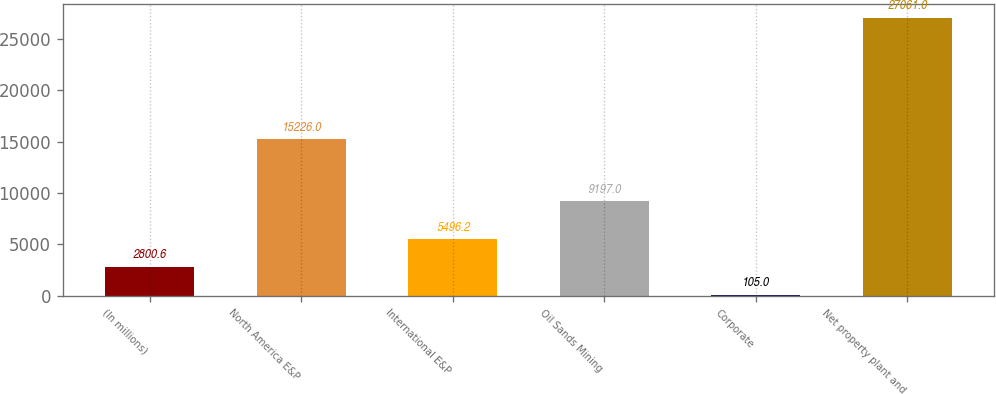Convert chart to OTSL. <chart><loc_0><loc_0><loc_500><loc_500><bar_chart><fcel>(In millions)<fcel>North America E&P<fcel>International E&P<fcel>Oil Sands Mining<fcel>Corporate<fcel>Net property plant and<nl><fcel>2800.6<fcel>15226<fcel>5496.2<fcel>9197<fcel>105<fcel>27061<nl></chart> 